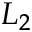Convert formula to latex. <formula><loc_0><loc_0><loc_500><loc_500>L _ { 2 }</formula> 